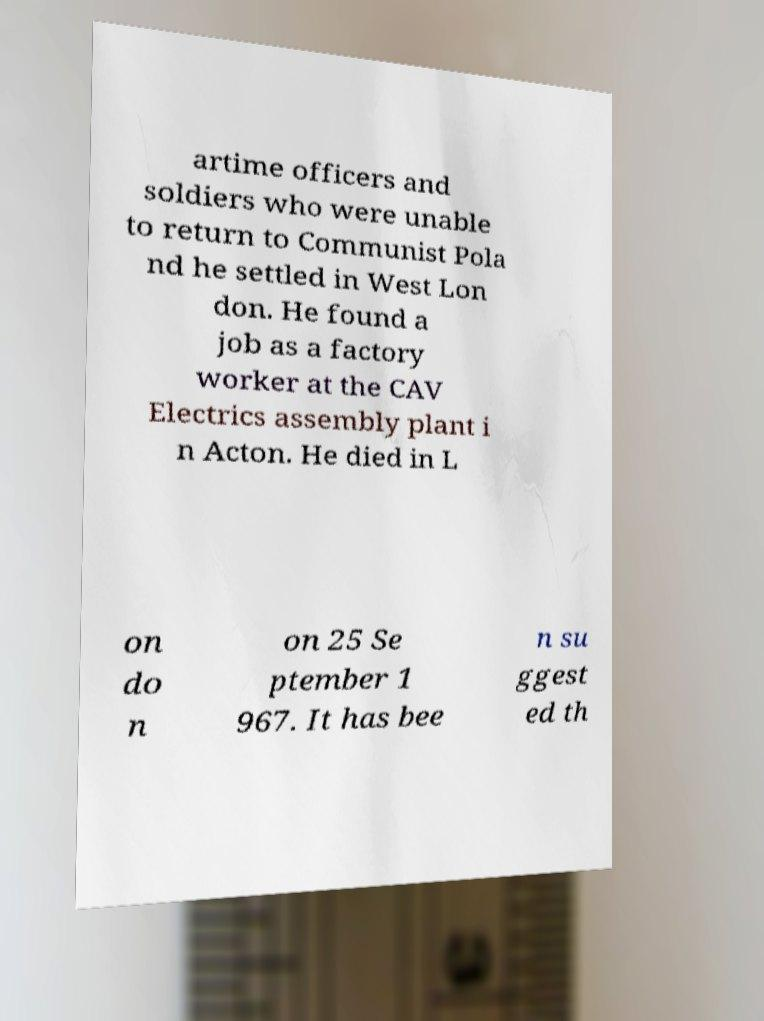Please identify and transcribe the text found in this image. artime officers and soldiers who were unable to return to Communist Pola nd he settled in West Lon don. He found a job as a factory worker at the CAV Electrics assembly plant i n Acton. He died in L on do n on 25 Se ptember 1 967. It has bee n su ggest ed th 